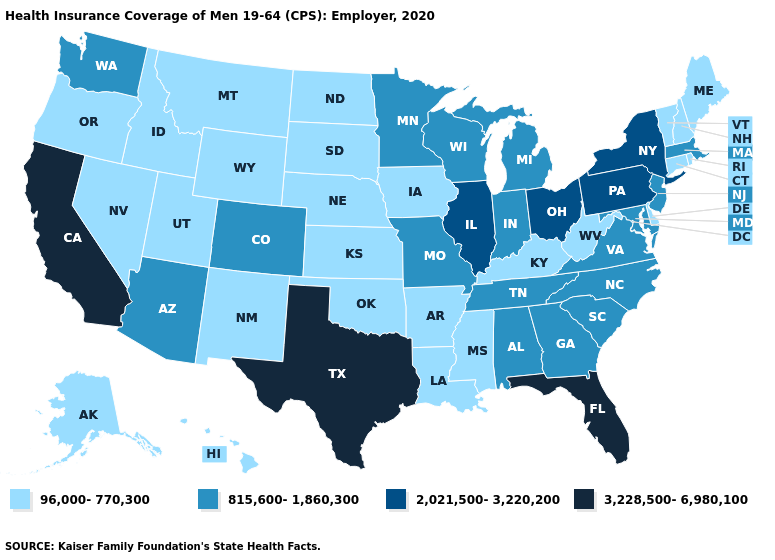Name the states that have a value in the range 2,021,500-3,220,200?
Be succinct. Illinois, New York, Ohio, Pennsylvania. Which states have the highest value in the USA?
Keep it brief. California, Florida, Texas. Does the first symbol in the legend represent the smallest category?
Quick response, please. Yes. What is the value of Virginia?
Concise answer only. 815,600-1,860,300. What is the highest value in the USA?
Be succinct. 3,228,500-6,980,100. How many symbols are there in the legend?
Short answer required. 4. What is the highest value in the Northeast ?
Keep it brief. 2,021,500-3,220,200. Among the states that border Nebraska , does South Dakota have the highest value?
Be succinct. No. What is the value of South Carolina?
Short answer required. 815,600-1,860,300. What is the lowest value in the USA?
Write a very short answer. 96,000-770,300. Name the states that have a value in the range 96,000-770,300?
Write a very short answer. Alaska, Arkansas, Connecticut, Delaware, Hawaii, Idaho, Iowa, Kansas, Kentucky, Louisiana, Maine, Mississippi, Montana, Nebraska, Nevada, New Hampshire, New Mexico, North Dakota, Oklahoma, Oregon, Rhode Island, South Dakota, Utah, Vermont, West Virginia, Wyoming. Is the legend a continuous bar?
Write a very short answer. No. What is the value of Idaho?
Concise answer only. 96,000-770,300. What is the value of Georgia?
Be succinct. 815,600-1,860,300. Does Michigan have the lowest value in the USA?
Quick response, please. No. 